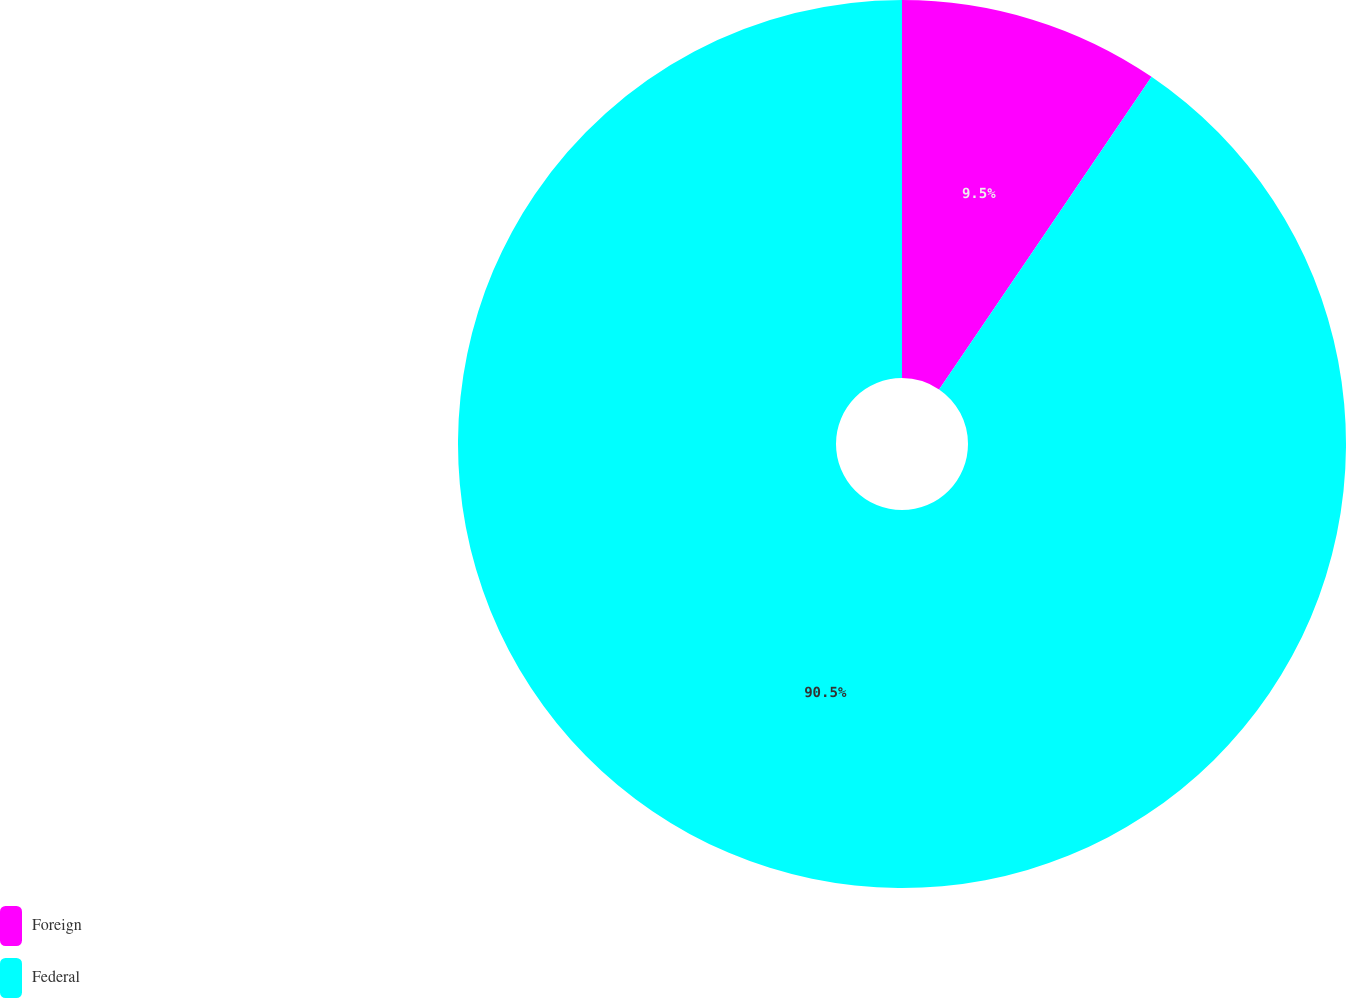Convert chart. <chart><loc_0><loc_0><loc_500><loc_500><pie_chart><fcel>Foreign<fcel>Federal<nl><fcel>9.5%<fcel>90.5%<nl></chart> 